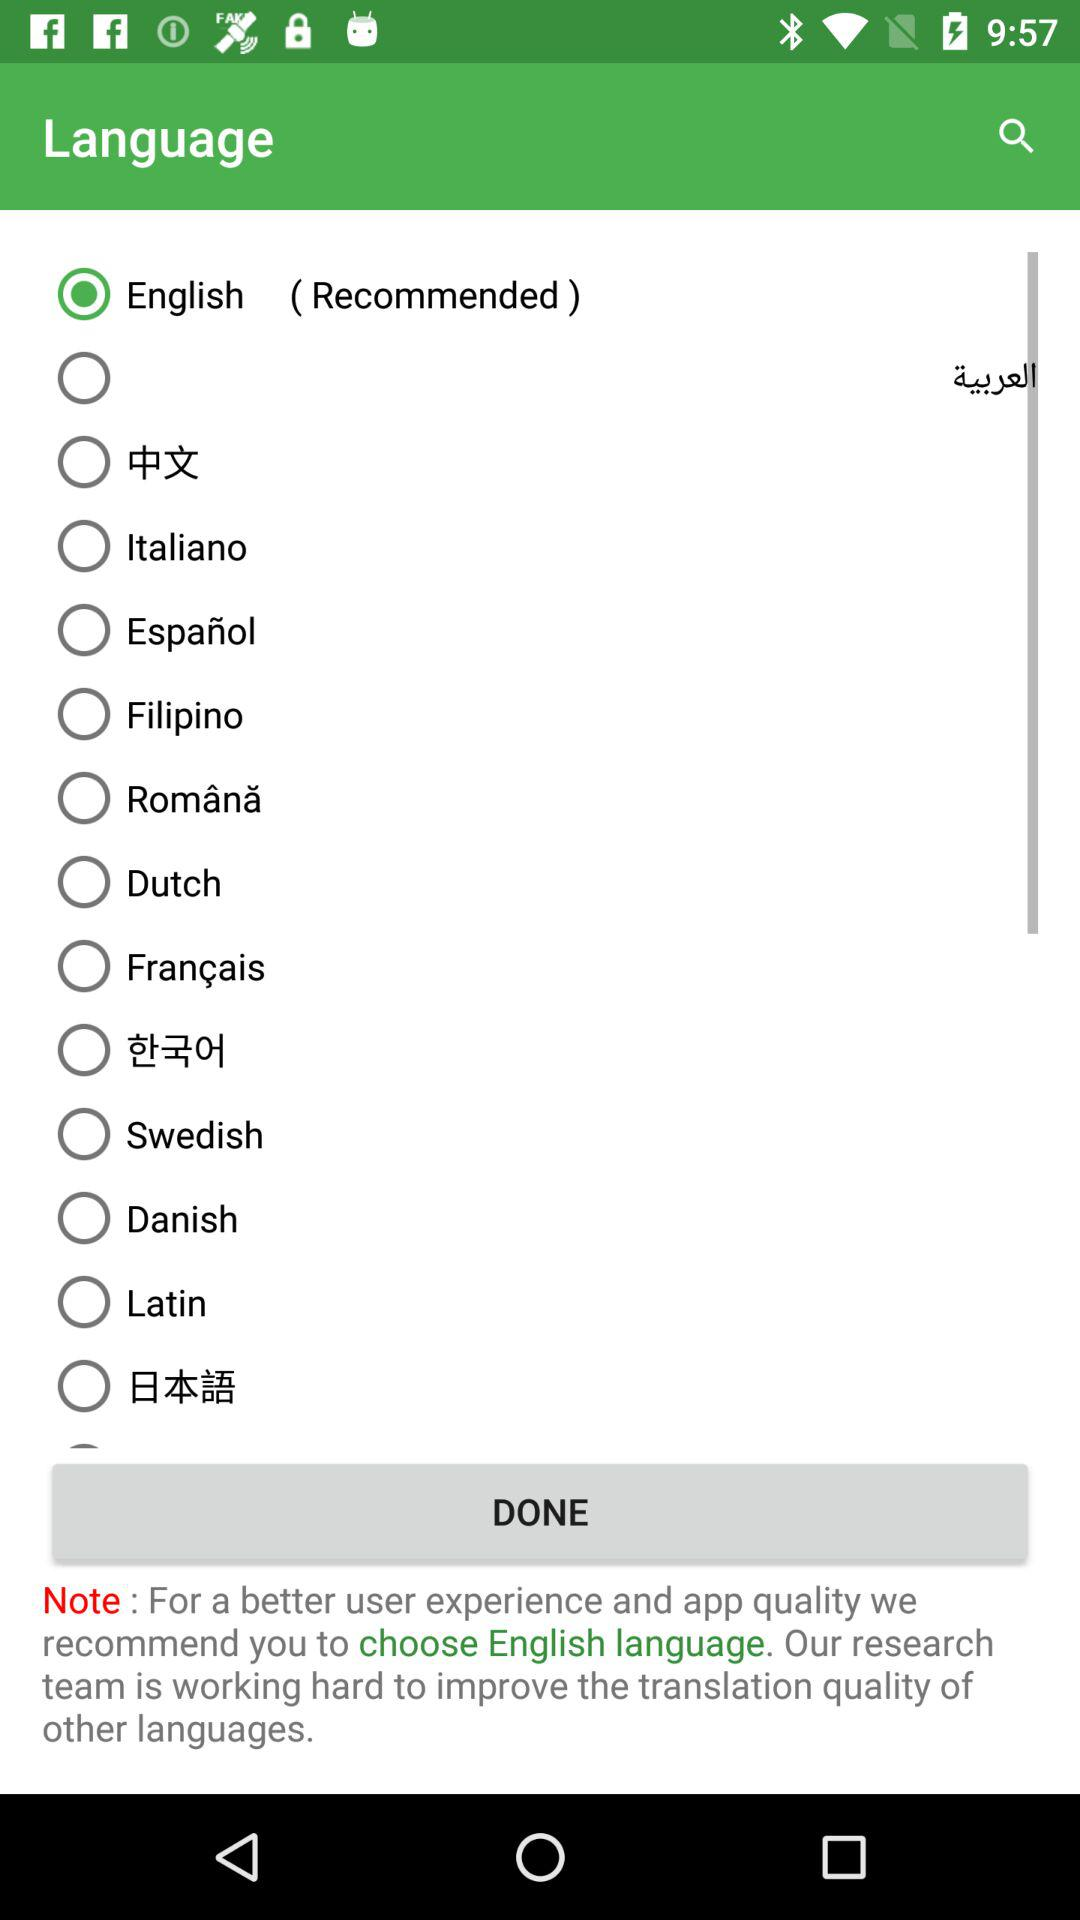What is the status of "Latin"? The status is "off". 